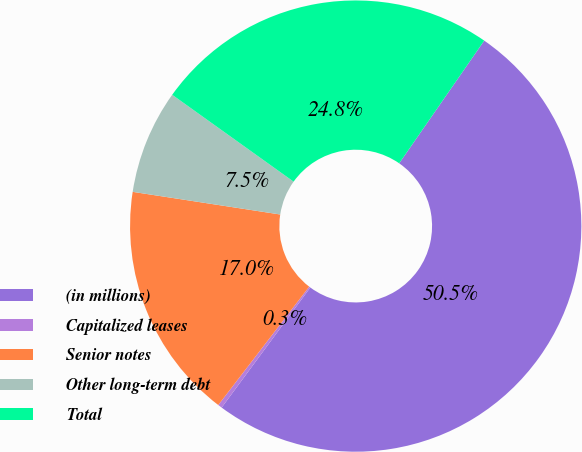<chart> <loc_0><loc_0><loc_500><loc_500><pie_chart><fcel>(in millions)<fcel>Capitalized leases<fcel>Senior notes<fcel>Other long-term debt<fcel>Total<nl><fcel>50.48%<fcel>0.3%<fcel>17.0%<fcel>7.46%<fcel>24.76%<nl></chart> 